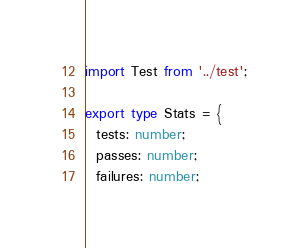Convert code to text. <code><loc_0><loc_0><loc_500><loc_500><_TypeScript_>import Test from '../test';

export type Stats = {
  tests: number;
  passes: number;
  failures: number;</code> 